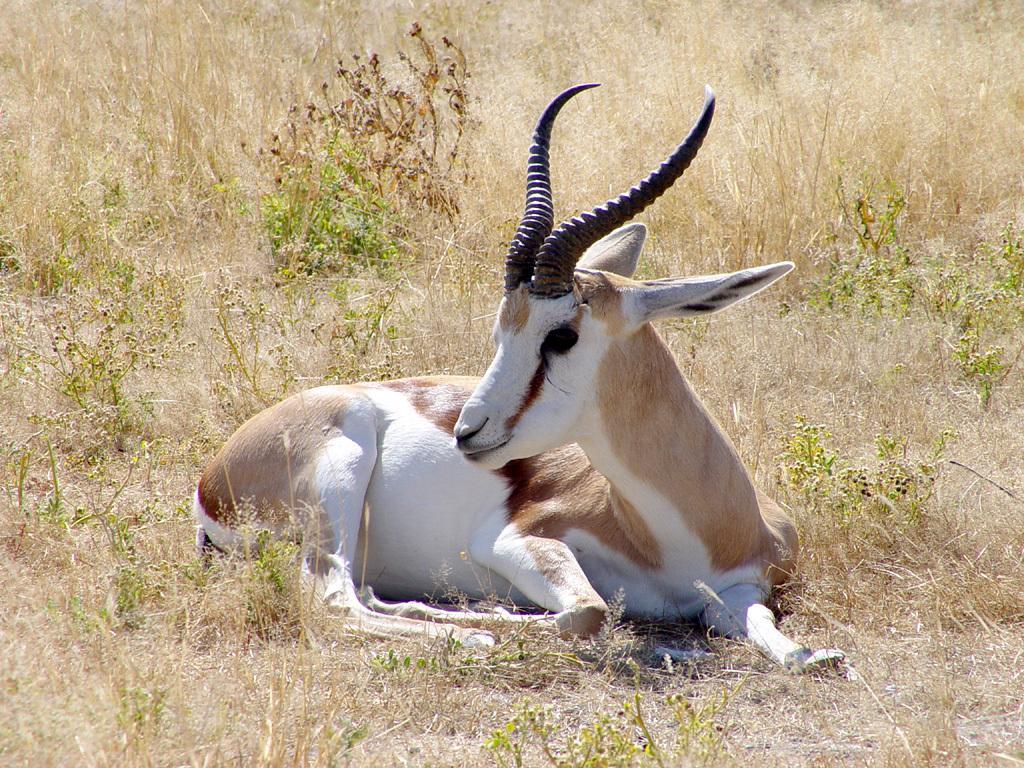Describe this image in one or two sentences. In this image, we can see a goat is sitting on the ground. Here we can see few plants and grass. 